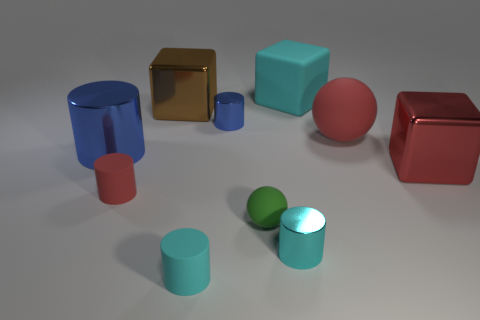What size is the cylinder that is both on the left side of the tiny blue shiny cylinder and in front of the green object?
Provide a succinct answer. Small. There is a red thing that is the same shape as the large blue shiny thing; what material is it?
Give a very brief answer. Rubber. Does the rubber cylinder behind the green ball have the same size as the cyan metallic object?
Keep it short and to the point. Yes. There is a matte object that is both left of the large matte sphere and behind the red matte cylinder; what color is it?
Your answer should be compact. Cyan. There is a small metallic cylinder in front of the large red sphere; what number of small cyan cylinders are behind it?
Provide a succinct answer. 0. Do the green thing and the brown metal object have the same shape?
Give a very brief answer. No. Is there any other thing of the same color as the small ball?
Provide a short and direct response. No. There is a large red rubber thing; is it the same shape as the red rubber thing that is on the left side of the brown thing?
Your response must be concise. No. What is the color of the big metallic cube right of the sphere that is behind the metallic block that is in front of the big sphere?
Make the answer very short. Red. Is there any other thing that has the same material as the large blue cylinder?
Ensure brevity in your answer.  Yes. 